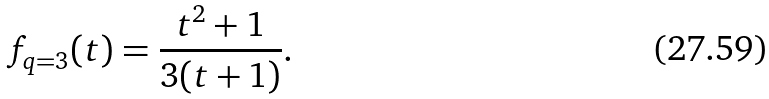Convert formula to latex. <formula><loc_0><loc_0><loc_500><loc_500>f _ { q = 3 } ( t ) = \frac { t ^ { 2 } + 1 } { 3 ( t + 1 ) } .</formula> 